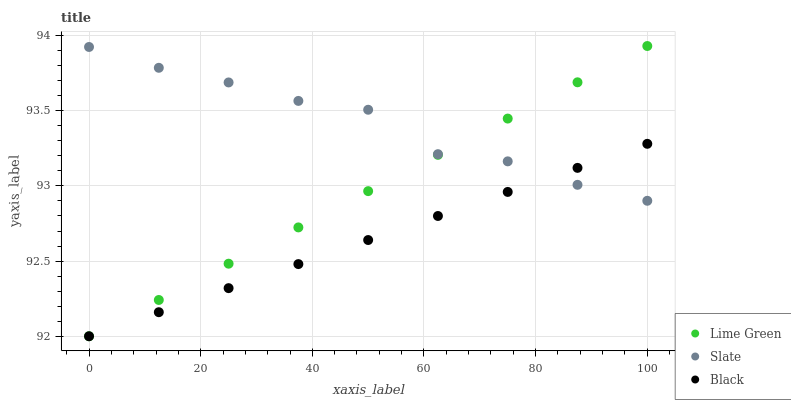Does Black have the minimum area under the curve?
Answer yes or no. Yes. Does Slate have the maximum area under the curve?
Answer yes or no. Yes. Does Lime Green have the minimum area under the curve?
Answer yes or no. No. Does Lime Green have the maximum area under the curve?
Answer yes or no. No. Is Black the smoothest?
Answer yes or no. Yes. Is Slate the roughest?
Answer yes or no. Yes. Is Lime Green the smoothest?
Answer yes or no. No. Is Lime Green the roughest?
Answer yes or no. No. Does Black have the lowest value?
Answer yes or no. Yes. Does Slate have the lowest value?
Answer yes or no. No. Does Lime Green have the highest value?
Answer yes or no. Yes. Does Slate have the highest value?
Answer yes or no. No. Does Slate intersect Lime Green?
Answer yes or no. Yes. Is Slate less than Lime Green?
Answer yes or no. No. Is Slate greater than Lime Green?
Answer yes or no. No. 